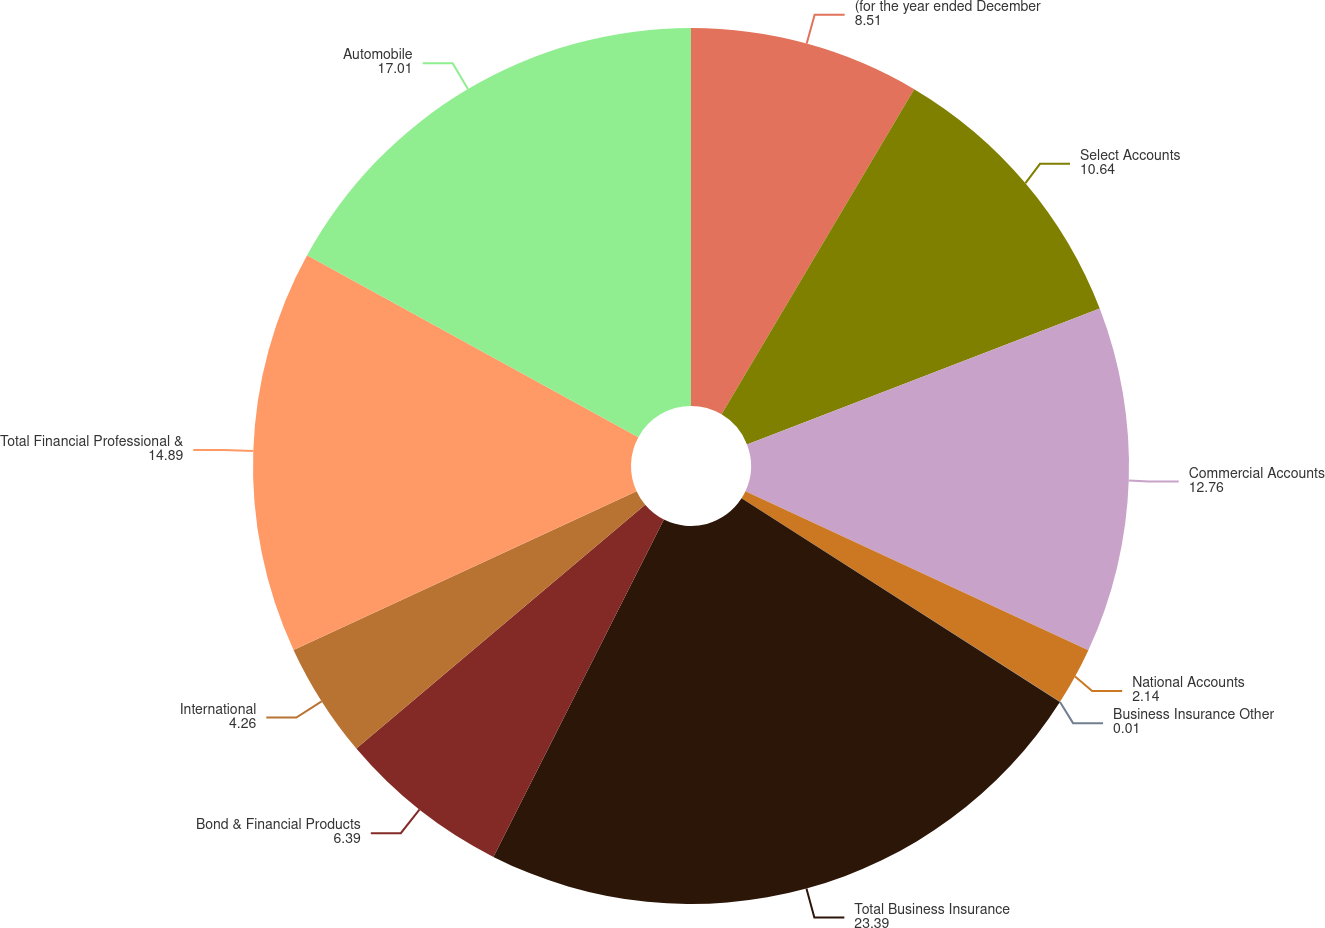<chart> <loc_0><loc_0><loc_500><loc_500><pie_chart><fcel>(for the year ended December<fcel>Select Accounts<fcel>Commercial Accounts<fcel>National Accounts<fcel>Business Insurance Other<fcel>Total Business Insurance<fcel>Bond & Financial Products<fcel>International<fcel>Total Financial Professional &<fcel>Automobile<nl><fcel>8.51%<fcel>10.64%<fcel>12.76%<fcel>2.14%<fcel>0.01%<fcel>23.39%<fcel>6.39%<fcel>4.26%<fcel>14.89%<fcel>17.01%<nl></chart> 